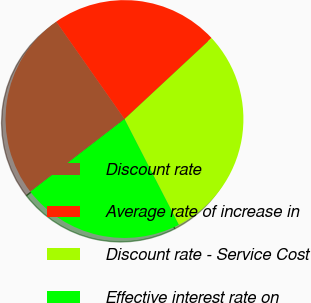Convert chart. <chart><loc_0><loc_0><loc_500><loc_500><pie_chart><fcel>Discount rate<fcel>Average rate of increase in<fcel>Discount rate - Service Cost<fcel>Effective interest rate on<nl><fcel>25.73%<fcel>22.8%<fcel>29.37%<fcel>22.09%<nl></chart> 